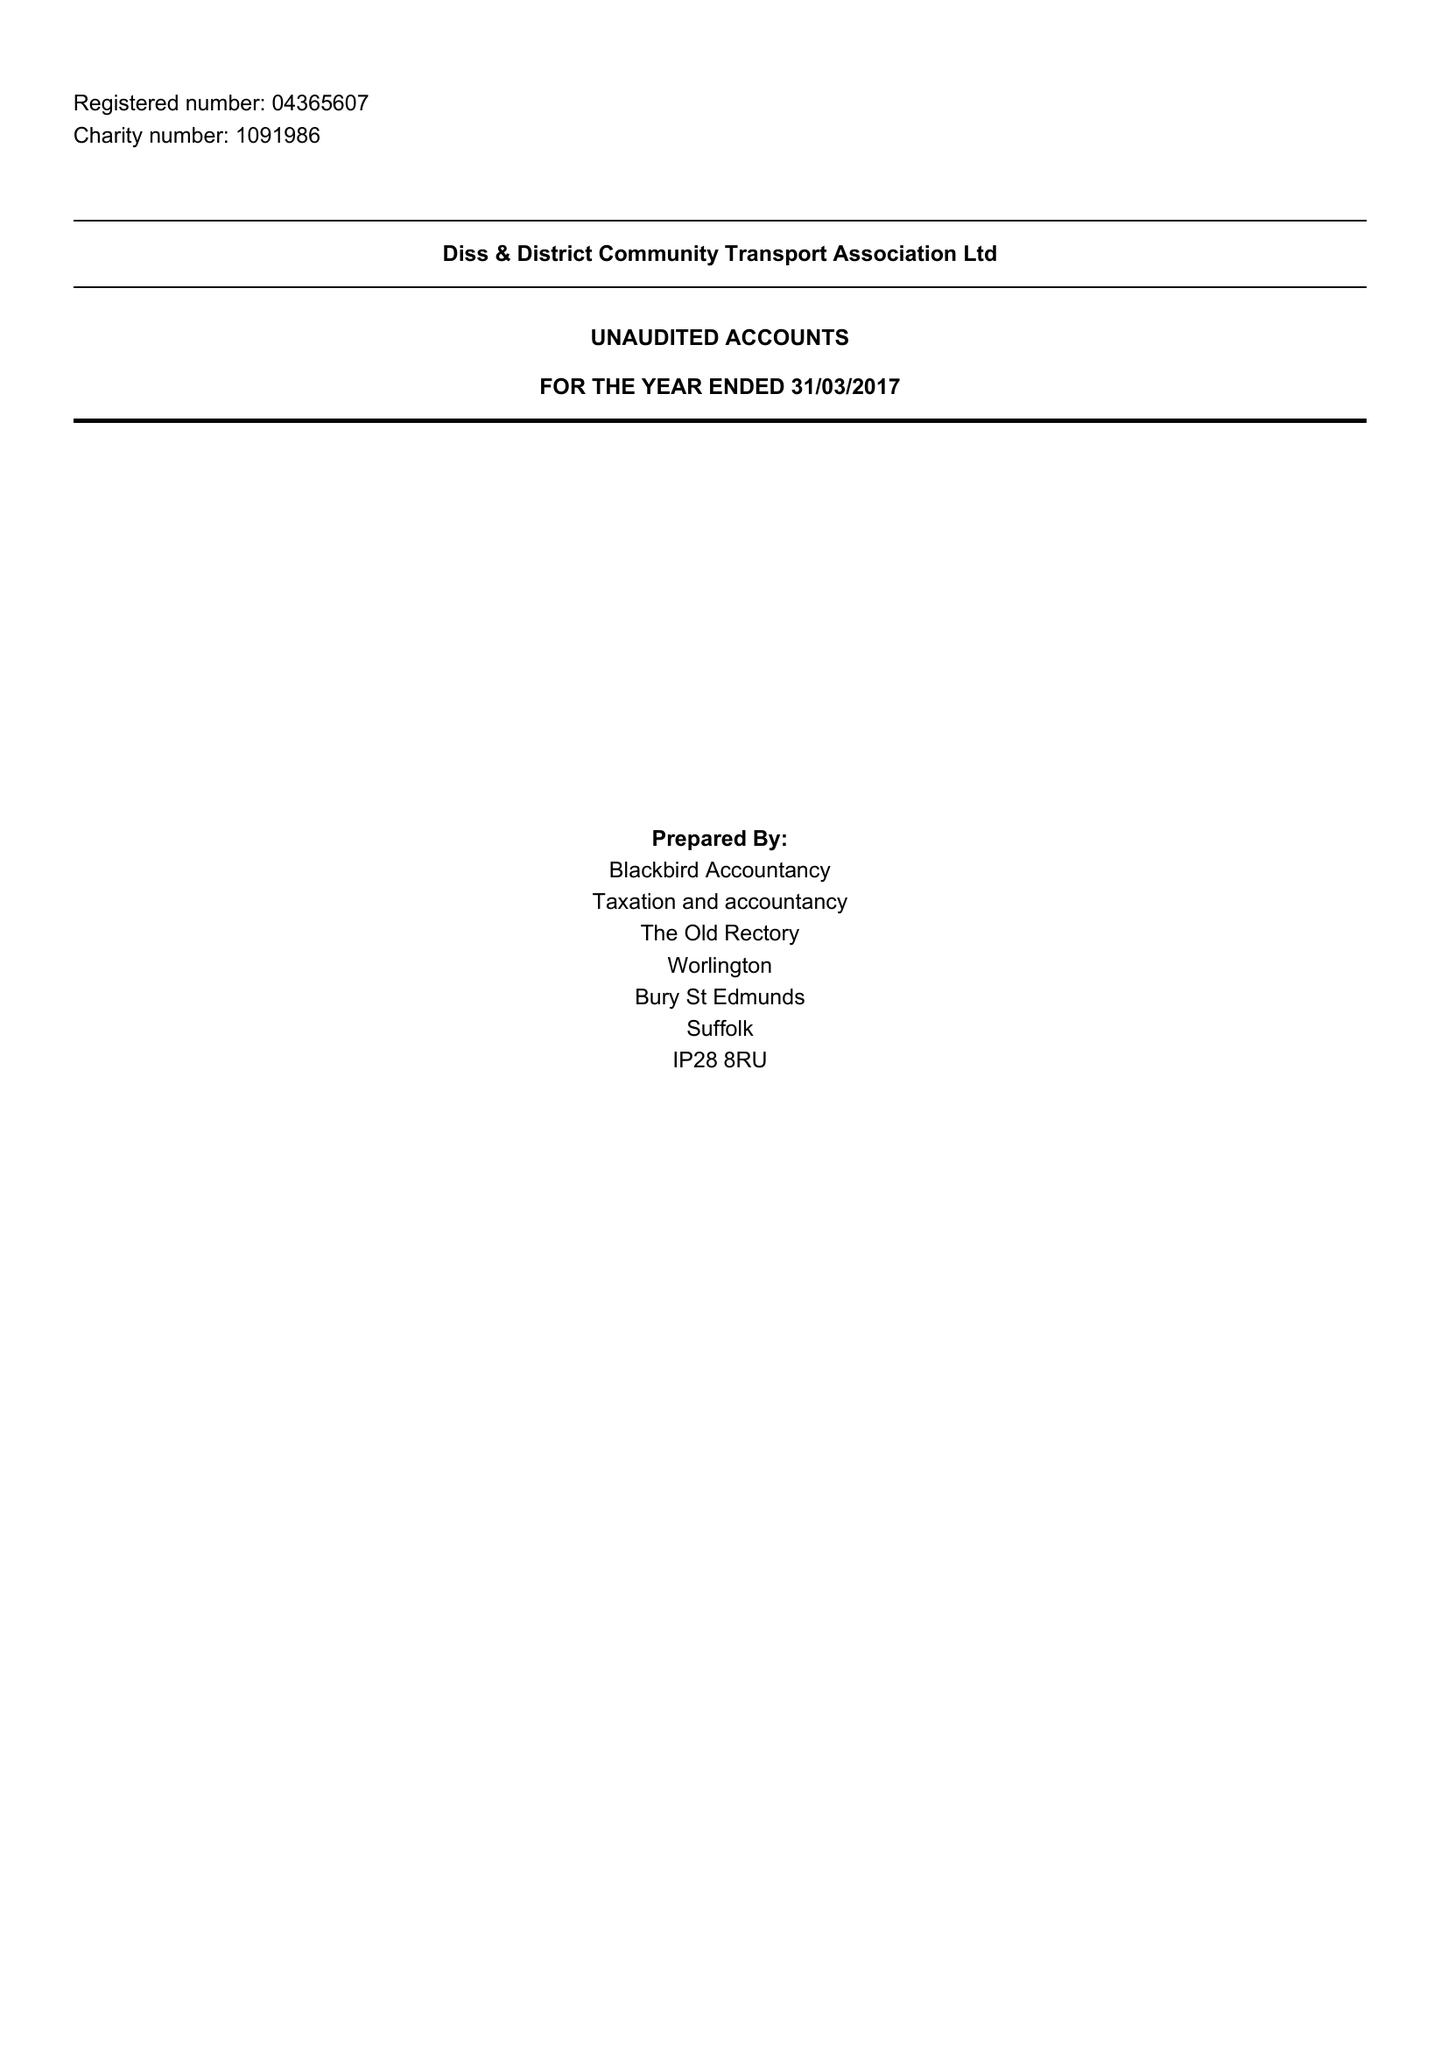What is the value for the charity_number?
Answer the question using a single word or phrase. 1091986 